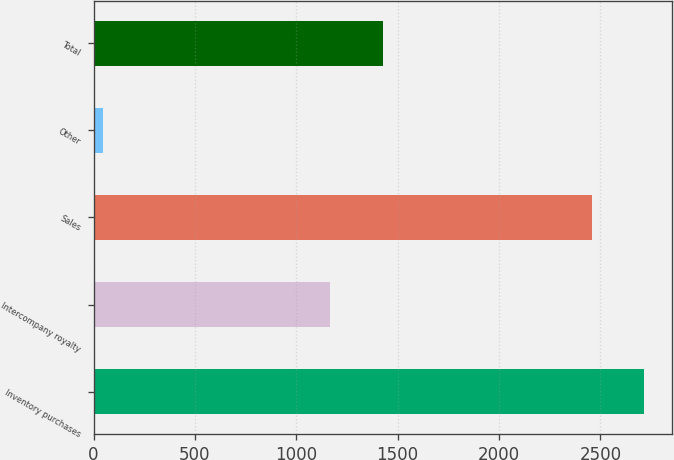<chart> <loc_0><loc_0><loc_500><loc_500><bar_chart><fcel>Inventory purchases<fcel>Intercompany royalty<fcel>Sales<fcel>Other<fcel>Total<nl><fcel>2717.3<fcel>1168<fcel>2458<fcel>45<fcel>1427.3<nl></chart> 